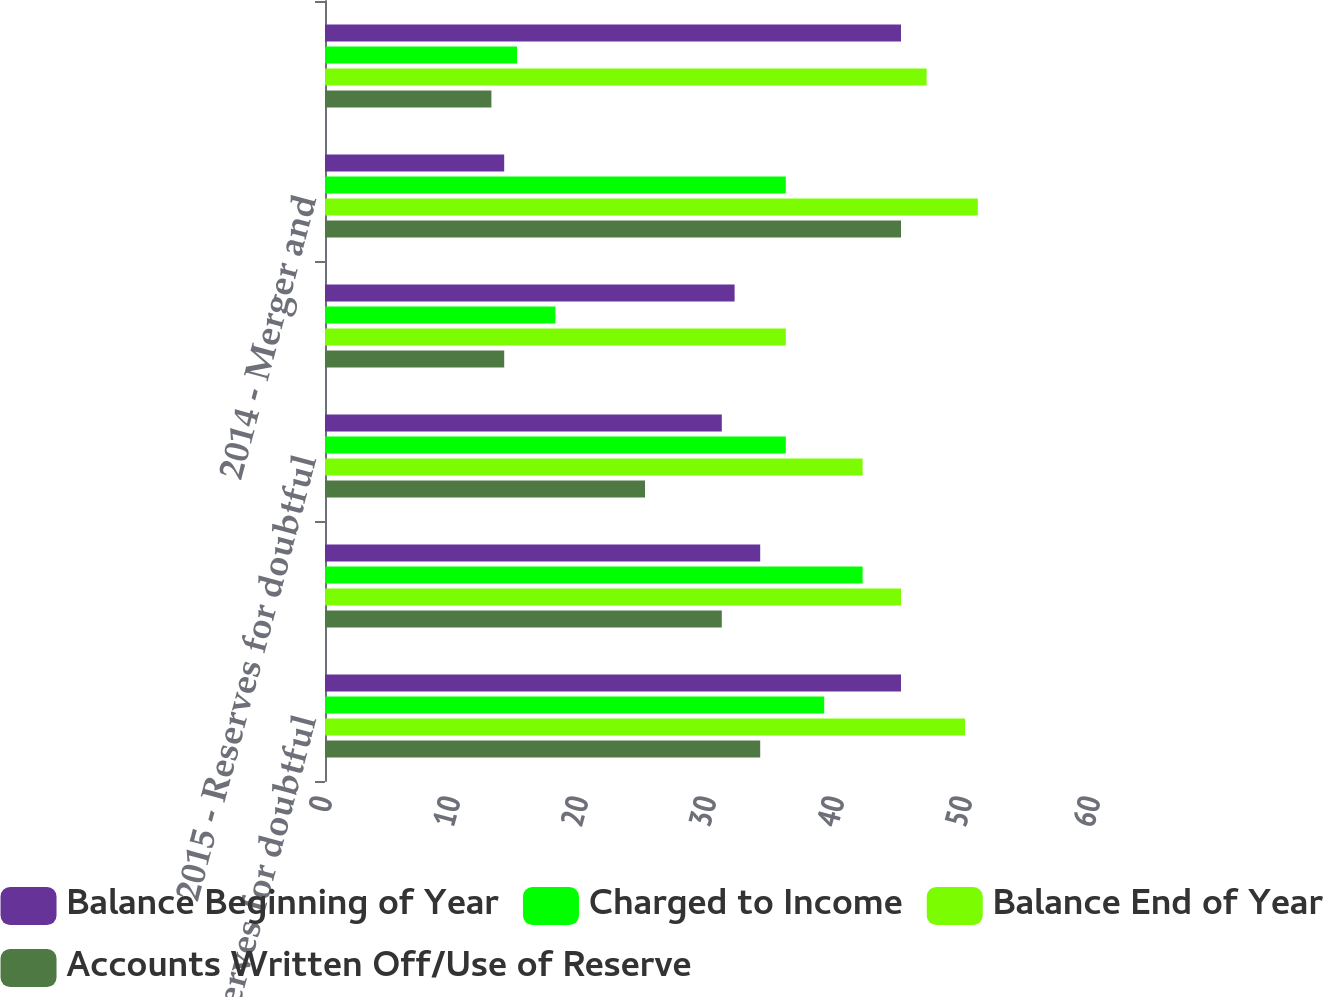<chart> <loc_0><loc_0><loc_500><loc_500><stacked_bar_chart><ecel><fcel>2013 - Reserves for doubtful<fcel>2014 - Reserves for doubtful<fcel>2015 - Reserves for doubtful<fcel>2013 - Merger and<fcel>2014 - Merger and<fcel>2015 - Merger and<nl><fcel>Balance Beginning of Year<fcel>45<fcel>34<fcel>31<fcel>32<fcel>14<fcel>45<nl><fcel>Charged to Income<fcel>39<fcel>42<fcel>36<fcel>18<fcel>36<fcel>15<nl><fcel>Balance End of Year<fcel>50<fcel>45<fcel>42<fcel>36<fcel>51<fcel>47<nl><fcel>Accounts Written Off/Use of Reserve<fcel>34<fcel>31<fcel>25<fcel>14<fcel>45<fcel>13<nl></chart> 